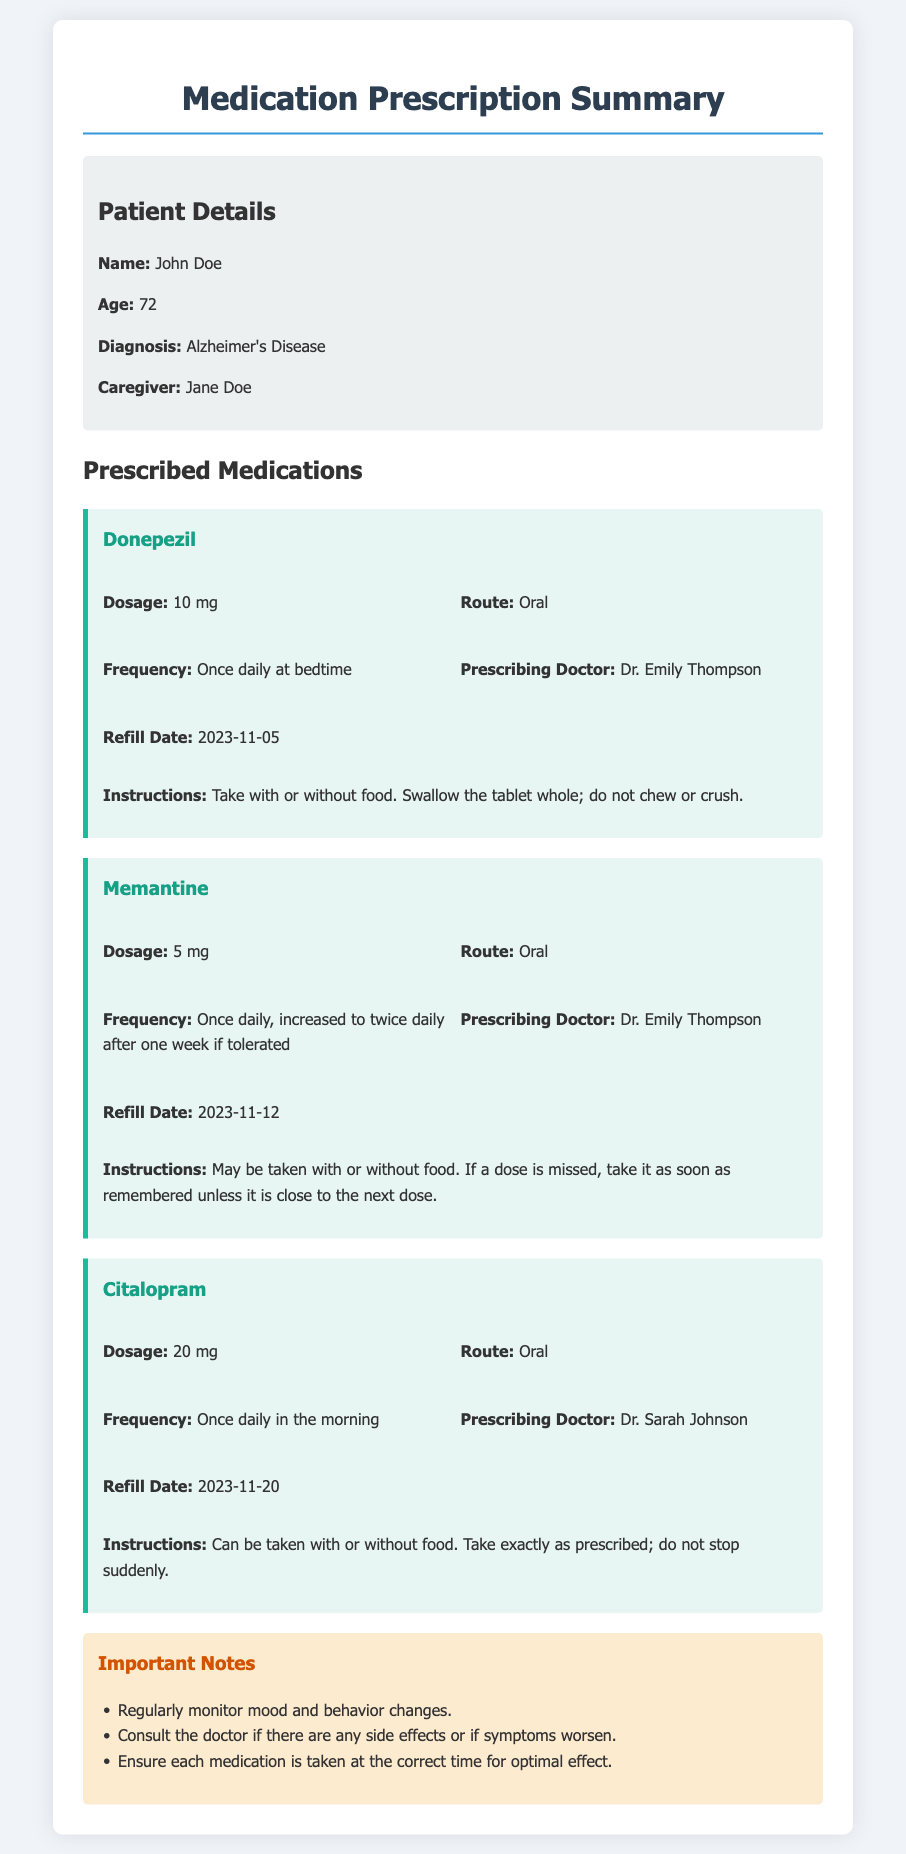What is the name of the patient? The patient's name is described in the patient details section of the document.
Answer: John Doe Who is the prescribing doctor for Donepezil? This information is listed under the medication details for Donepezil.
Answer: Dr. Emily Thompson What is the dosage for Memantine? The dosage for Memantine is indicated in its specific section in the document.
Answer: 5 mg When is the refill date for Citalopram? The refill date can be found in the medication details for Citalopram.
Answer: 2023-11-20 What should be done if a dose of Memantine is missed? This instruction is clearly outlined in the section detailing the instructions for Memantine.
Answer: Take it as soon as remembered unless it is close to the next dose How often should Citalopram be taken? This information is specified in the frequency section for Citalopram.
Answer: Once daily in the morning What dietary restrictions are mentioned for Donepezil? The instructions for Donepezil include comments on dietary intake.
Answer: Take with or without food How many medications are listed in the document? The document contains distinct sections for each medication that give the total number prescribed.
Answer: Three 